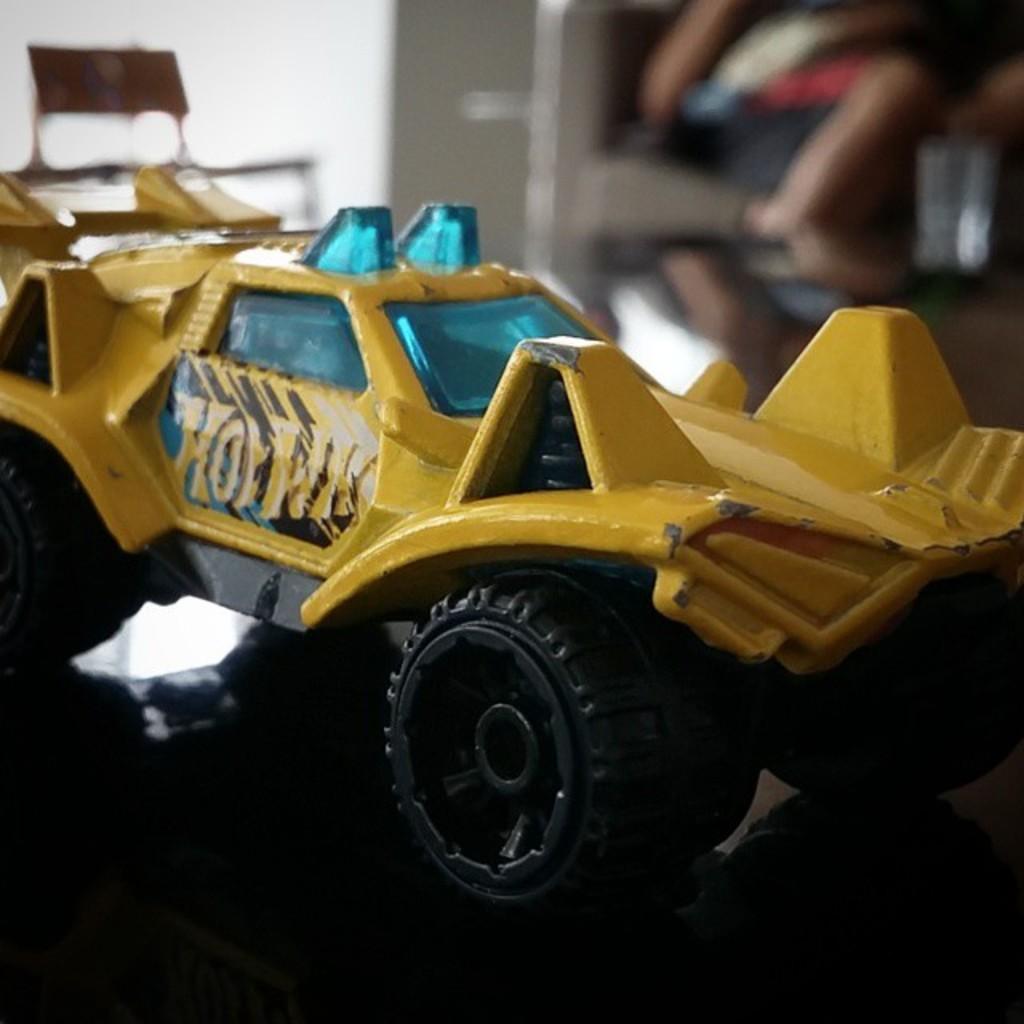Please provide a concise description of this image. In this image we can see a toy vehicle on a platform. In the background the image is blur but we can see objects. 